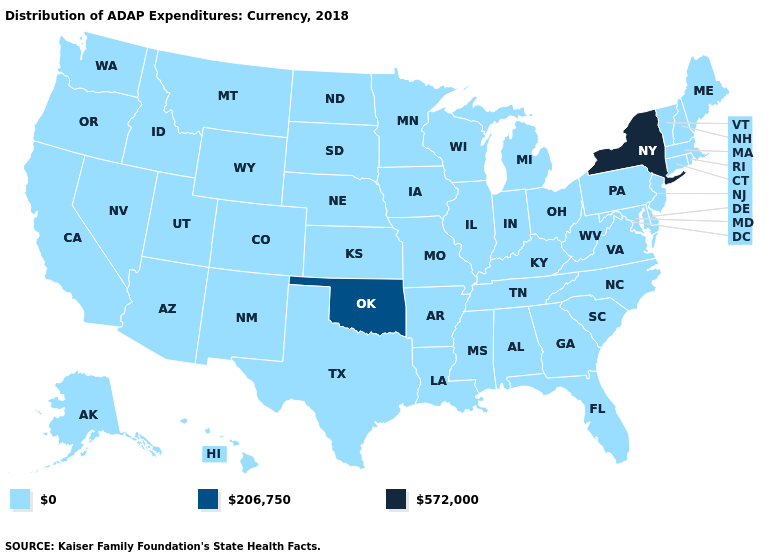What is the value of Massachusetts?
Keep it brief. 0. Does New York have the lowest value in the USA?
Give a very brief answer. No. Does the map have missing data?
Write a very short answer. No. What is the highest value in the USA?
Be succinct. 572,000. Does the map have missing data?
Keep it brief. No. What is the highest value in states that border Pennsylvania?
Be succinct. 572,000. Which states have the highest value in the USA?
Quick response, please. New York. Name the states that have a value in the range 206,750?
Give a very brief answer. Oklahoma. Does New York have the highest value in the Northeast?
Concise answer only. Yes. Does the first symbol in the legend represent the smallest category?
Be succinct. Yes. Name the states that have a value in the range 572,000?
Write a very short answer. New York. What is the lowest value in the USA?
Concise answer only. 0. Among the states that border Pennsylvania , which have the highest value?
Answer briefly. New York. What is the value of Wisconsin?
Concise answer only. 0. Which states have the lowest value in the USA?
Concise answer only. Alabama, Alaska, Arizona, Arkansas, California, Colorado, Connecticut, Delaware, Florida, Georgia, Hawaii, Idaho, Illinois, Indiana, Iowa, Kansas, Kentucky, Louisiana, Maine, Maryland, Massachusetts, Michigan, Minnesota, Mississippi, Missouri, Montana, Nebraska, Nevada, New Hampshire, New Jersey, New Mexico, North Carolina, North Dakota, Ohio, Oregon, Pennsylvania, Rhode Island, South Carolina, South Dakota, Tennessee, Texas, Utah, Vermont, Virginia, Washington, West Virginia, Wisconsin, Wyoming. 